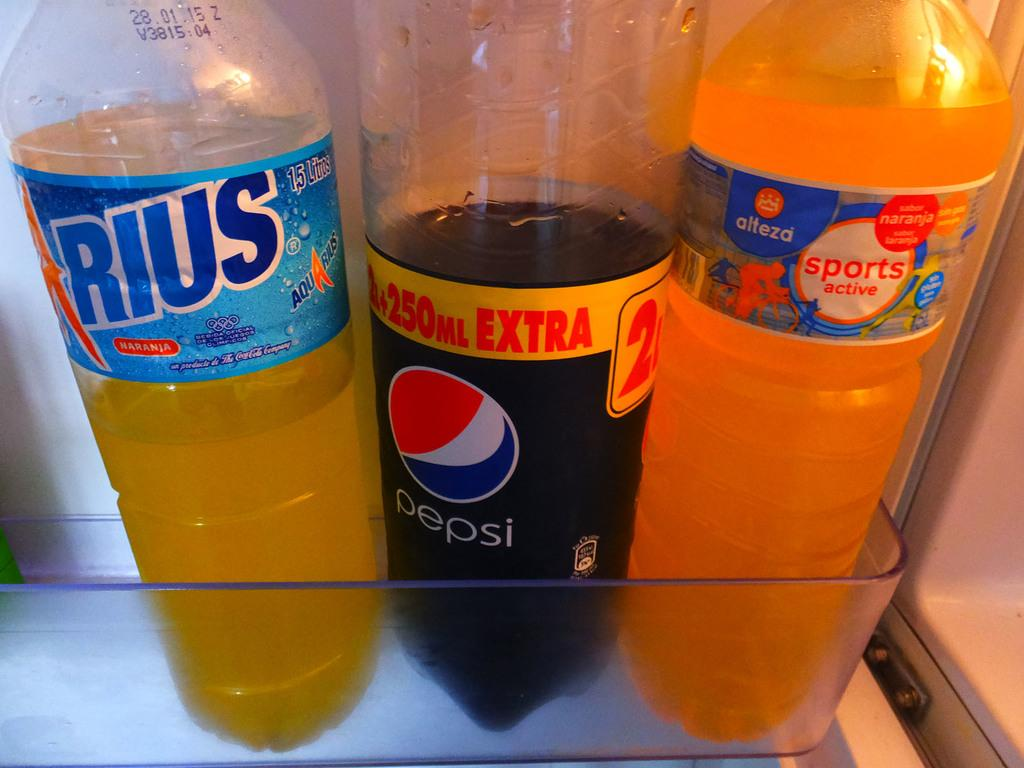<image>
Provide a brief description of the given image. a Pepsi bottle is next to two others 